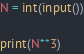<code> <loc_0><loc_0><loc_500><loc_500><_Python_>N = int(input())

print(N**3)</code> 